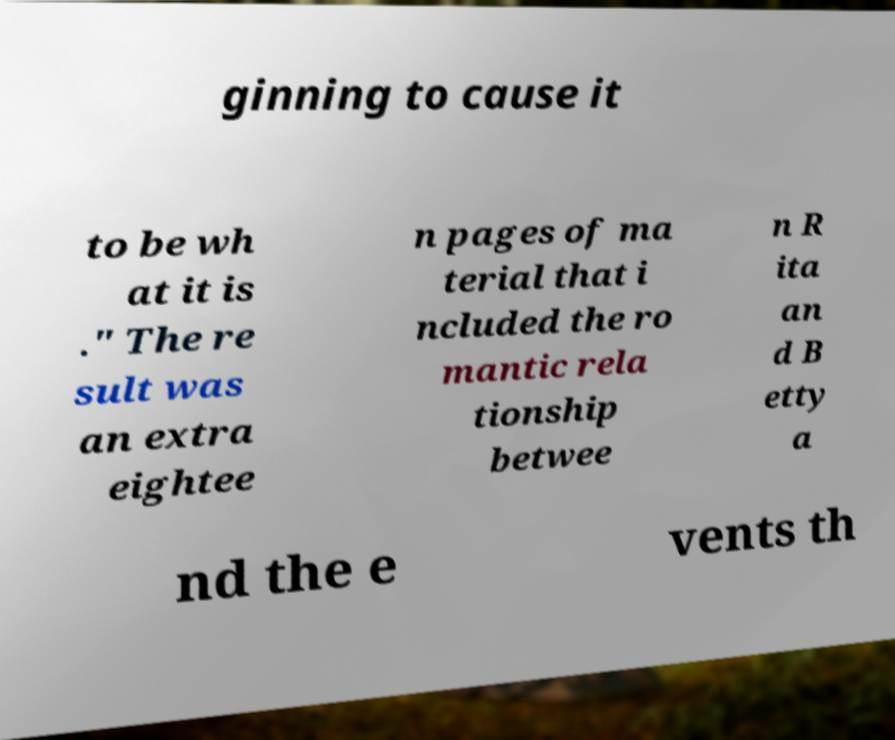Can you read and provide the text displayed in the image?This photo seems to have some interesting text. Can you extract and type it out for me? ginning to cause it to be wh at it is ." The re sult was an extra eightee n pages of ma terial that i ncluded the ro mantic rela tionship betwee n R ita an d B etty a nd the e vents th 